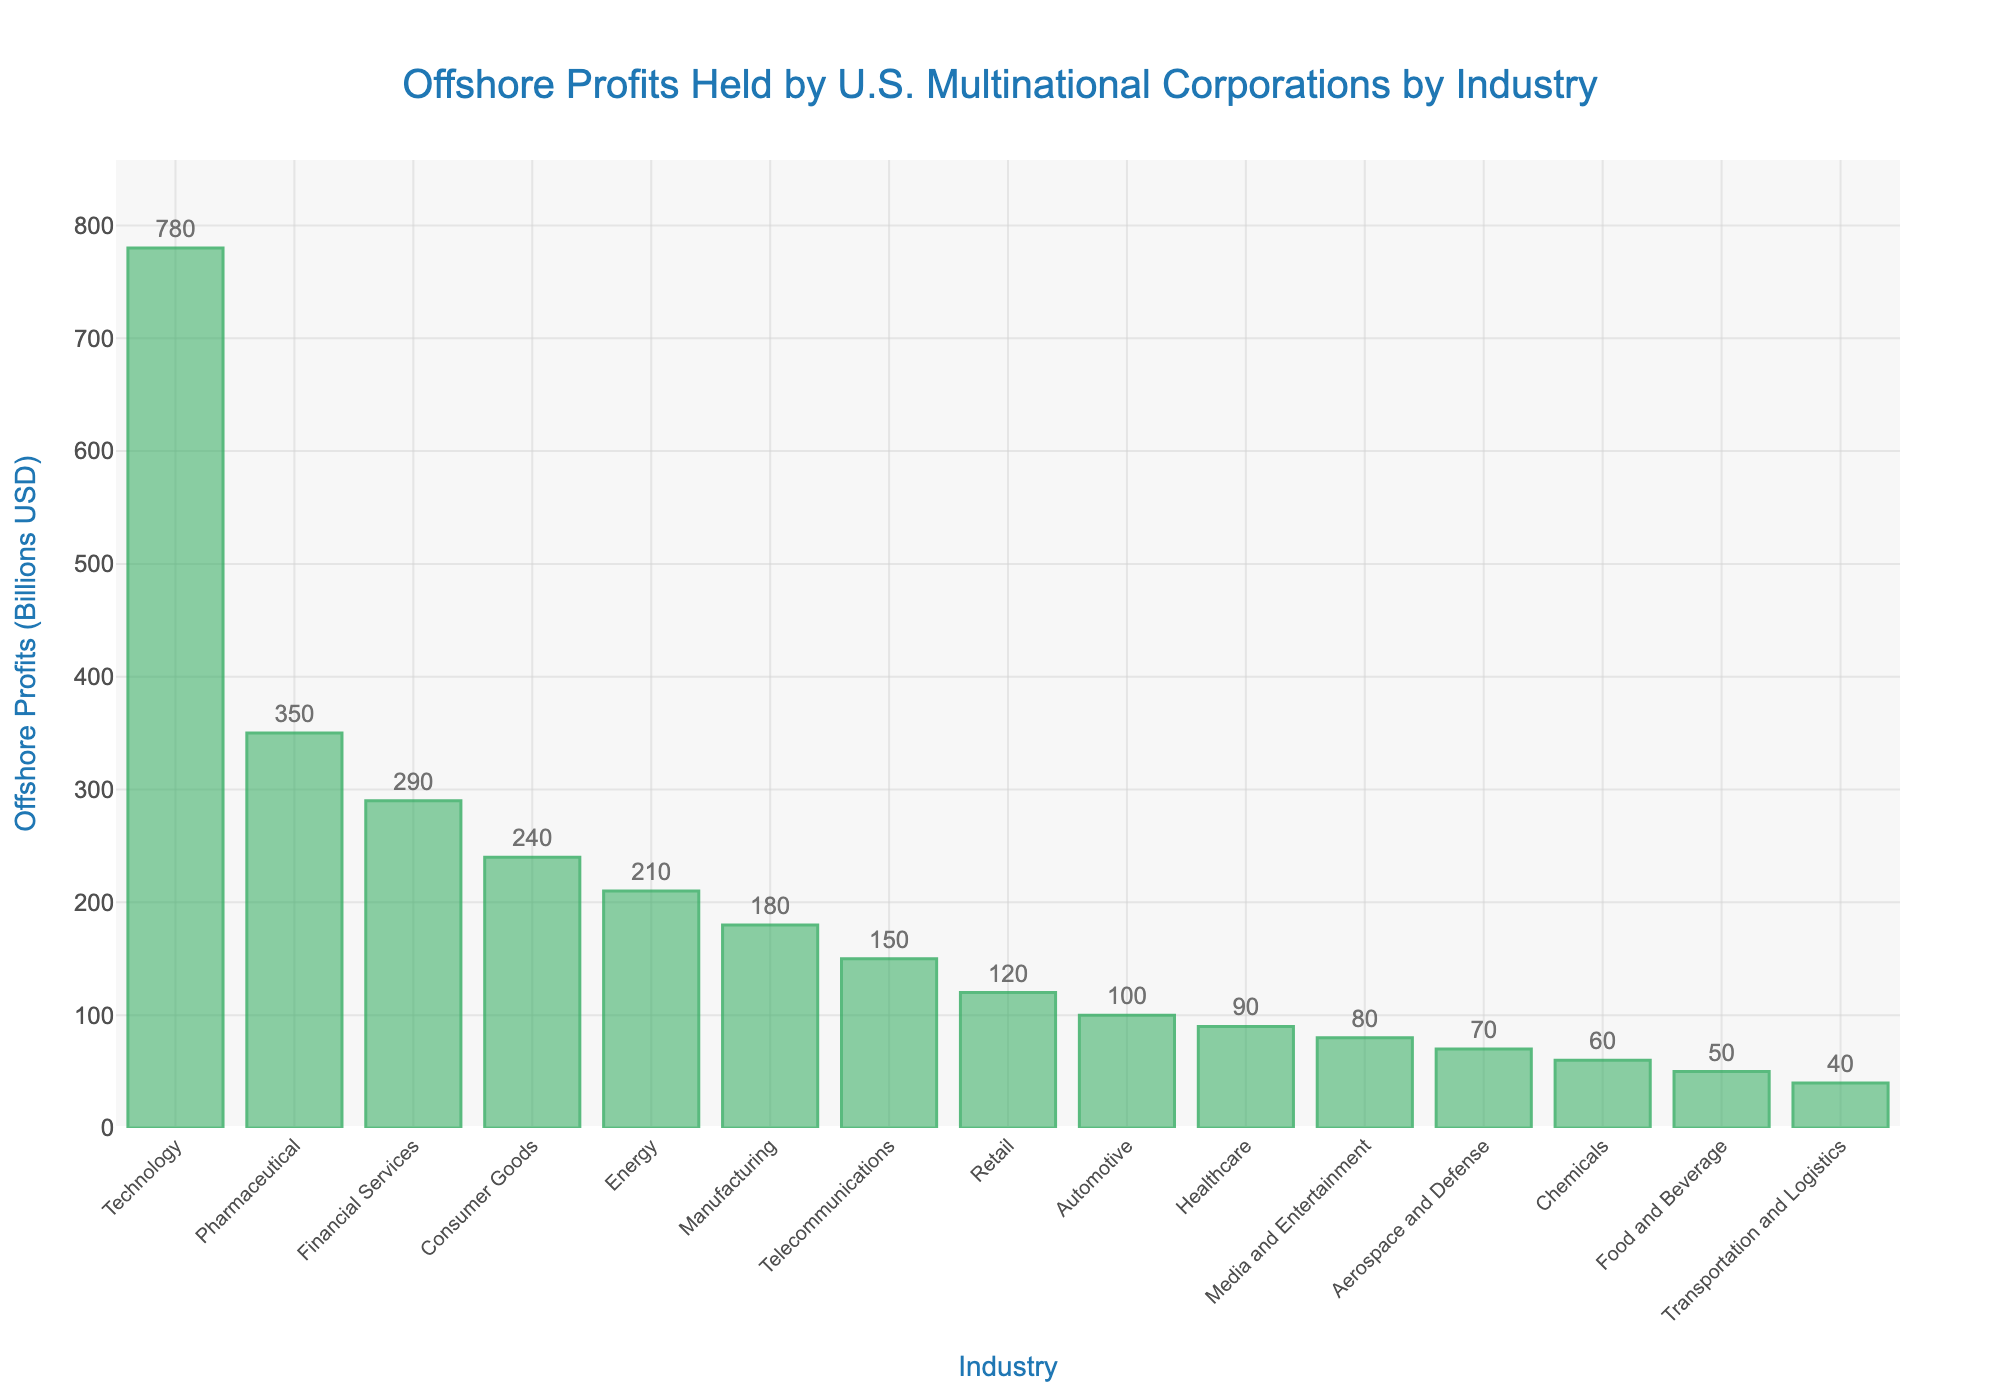Which industry holds the highest amount of offshore profits? By looking at the tallest bar in the bar chart, we can see that the Technology industry has the highest offshore profits of 780 billion USD.
Answer: Technology How much more offshore profit does the Technology sector have compared to the Pharmaceutical sector? The bar for the Technology sector shows 780 billion USD, whereas the Pharmaceutical sector shows 350 billion USD. The difference is 780 - 350 = 430 billion USD.
Answer: 430 billion USD Which industry holds the lowest amount of offshore profits? By identifying the shortest bar in the chart, we can see that the Transportation and Logistics industry holds the lowest offshore profits at 40 billion USD.
Answer: Transportation and Logistics What is the combined offshore profit for the Financial Services and Consumer Goods sectors? The Financial Services sector has 290 billion USD and the Consumer Goods sector has 240 billion USD. Combined, it's 290 + 240 = 530 billion USD.
Answer: 530 billion USD How does the offshore profit of the Retail sector compare to that of the Healthcare sector? The Retail sector holds 120 billion USD in offshore profits, while the Healthcare sector holds 90 billion USD. The Retail sector's offshore profit is 120 - 90 = 30 billion USD more than the Healthcare sector's.
Answer: 30 billion USD more What is the median value of offshore profits across all industries listed? To find the median value, sort the offshore profits and find the middle value. The sorted values are [40, 50, 60, 70, 80, 90, 100, 120, 150, 180, 210, 240, 290, 350, 780]. The median, being the middle value in this ordered list of 15 elements, is 120 billion USD.
Answer: 120 billion USD By how much does the Energy sector's offshore profits exceed the Manufacturing sector's offshore profits? The Energy sector has 210 billion USD and the Manufacturing sector has 180 billion USD. The difference is 210 - 180 = 30 billion USD.
Answer: 30 billion USD What is the average offshore profit for the Telecommunications, Retail, and Automotive sectors combined? Sum the offshore profits for these sectors: 150 (Telecommunications) + 120 (Retail) + 100 (Automotive) = 370 billion USD. There are three sectors, so the average is 370 / 3 ≈ 123.33 billion USD.
Answer: 123.33 billion USD What is the total offshore profit held by the top three industries? The top three industries are Technology (780 billion USD), Pharmaceutical (350 billion USD), and Financial Services (290 billion USD). The total is 780 + 350 + 290 = 1420 billion USD.
Answer: 1420 billion USD Which industries have offshore profits greater than 200 billion USD? By observing the bars taller than the 200 billion USD mark, the industries are Technology (780 billion USD), Pharmaceutical (350 billion USD), Financial Services (290 billion USD), Consumer Goods (240 billion USD), and Energy (210 billion USD).
Answer: Technology, Pharmaceutical, Financial Services, Consumer Goods, Energy 